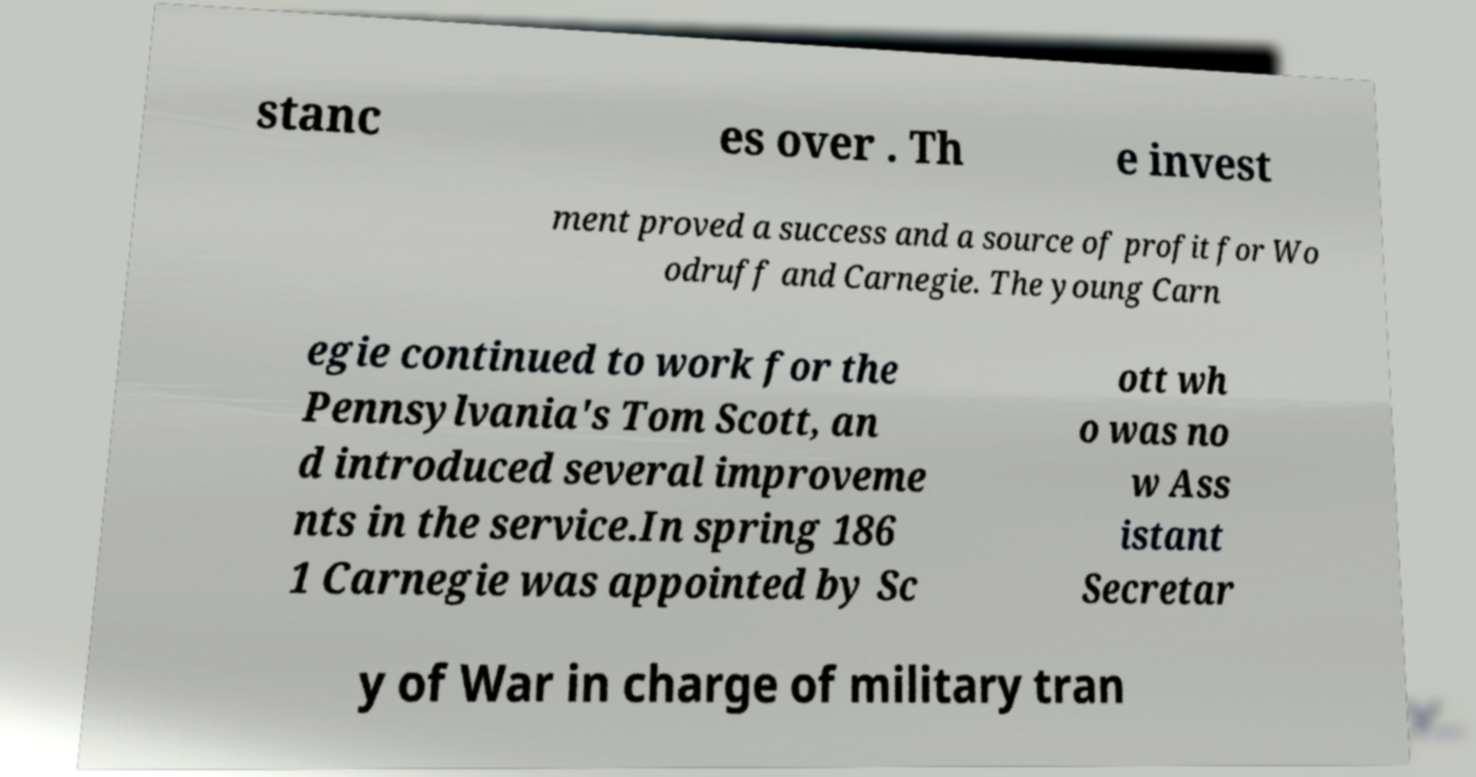Please read and relay the text visible in this image. What does it say? stanc es over . Th e invest ment proved a success and a source of profit for Wo odruff and Carnegie. The young Carn egie continued to work for the Pennsylvania's Tom Scott, an d introduced several improveme nts in the service.In spring 186 1 Carnegie was appointed by Sc ott wh o was no w Ass istant Secretar y of War in charge of military tran 